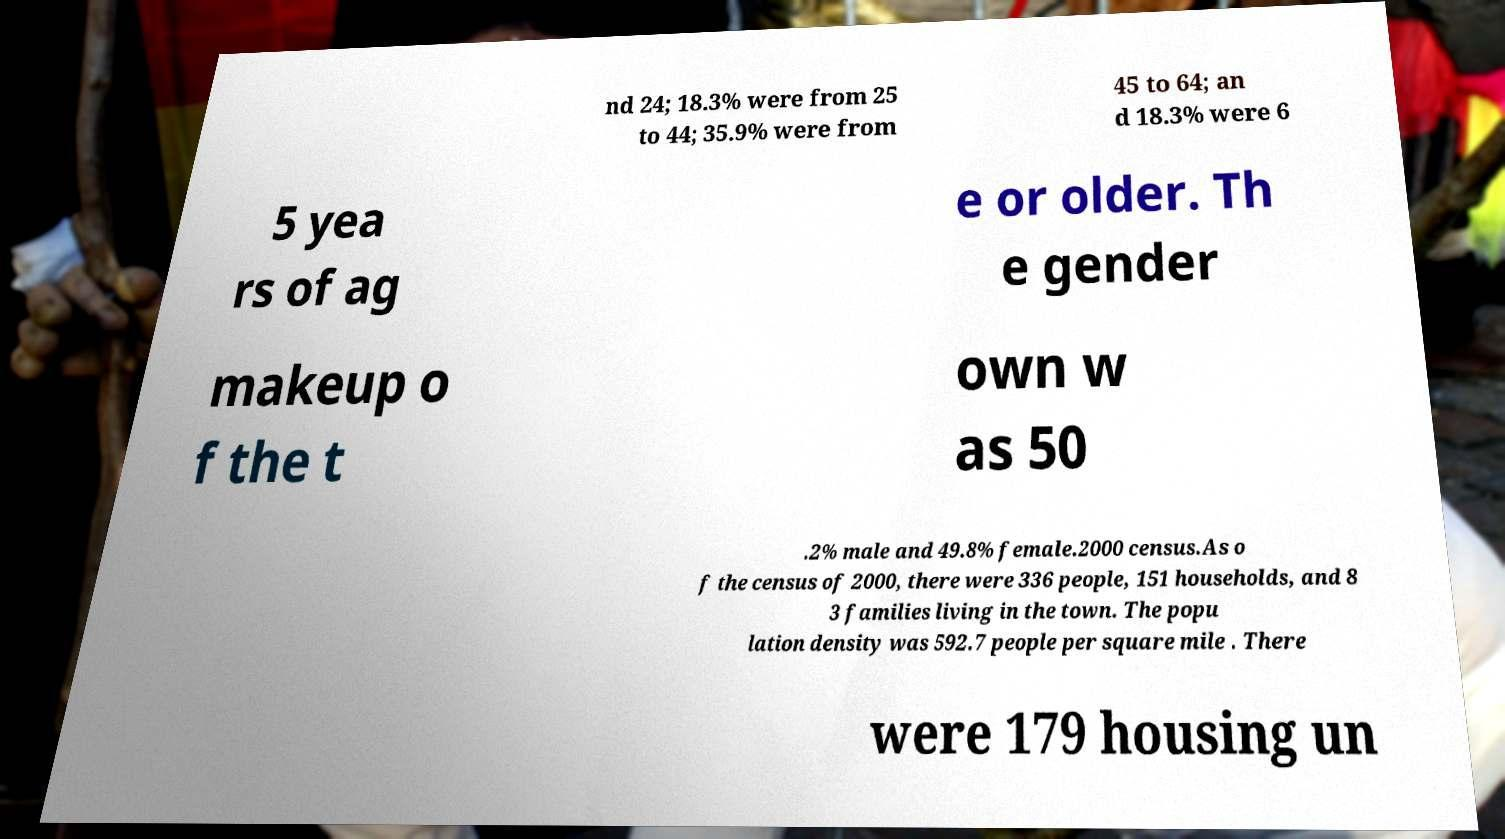I need the written content from this picture converted into text. Can you do that? nd 24; 18.3% were from 25 to 44; 35.9% were from 45 to 64; an d 18.3% were 6 5 yea rs of ag e or older. Th e gender makeup o f the t own w as 50 .2% male and 49.8% female.2000 census.As o f the census of 2000, there were 336 people, 151 households, and 8 3 families living in the town. The popu lation density was 592.7 people per square mile . There were 179 housing un 